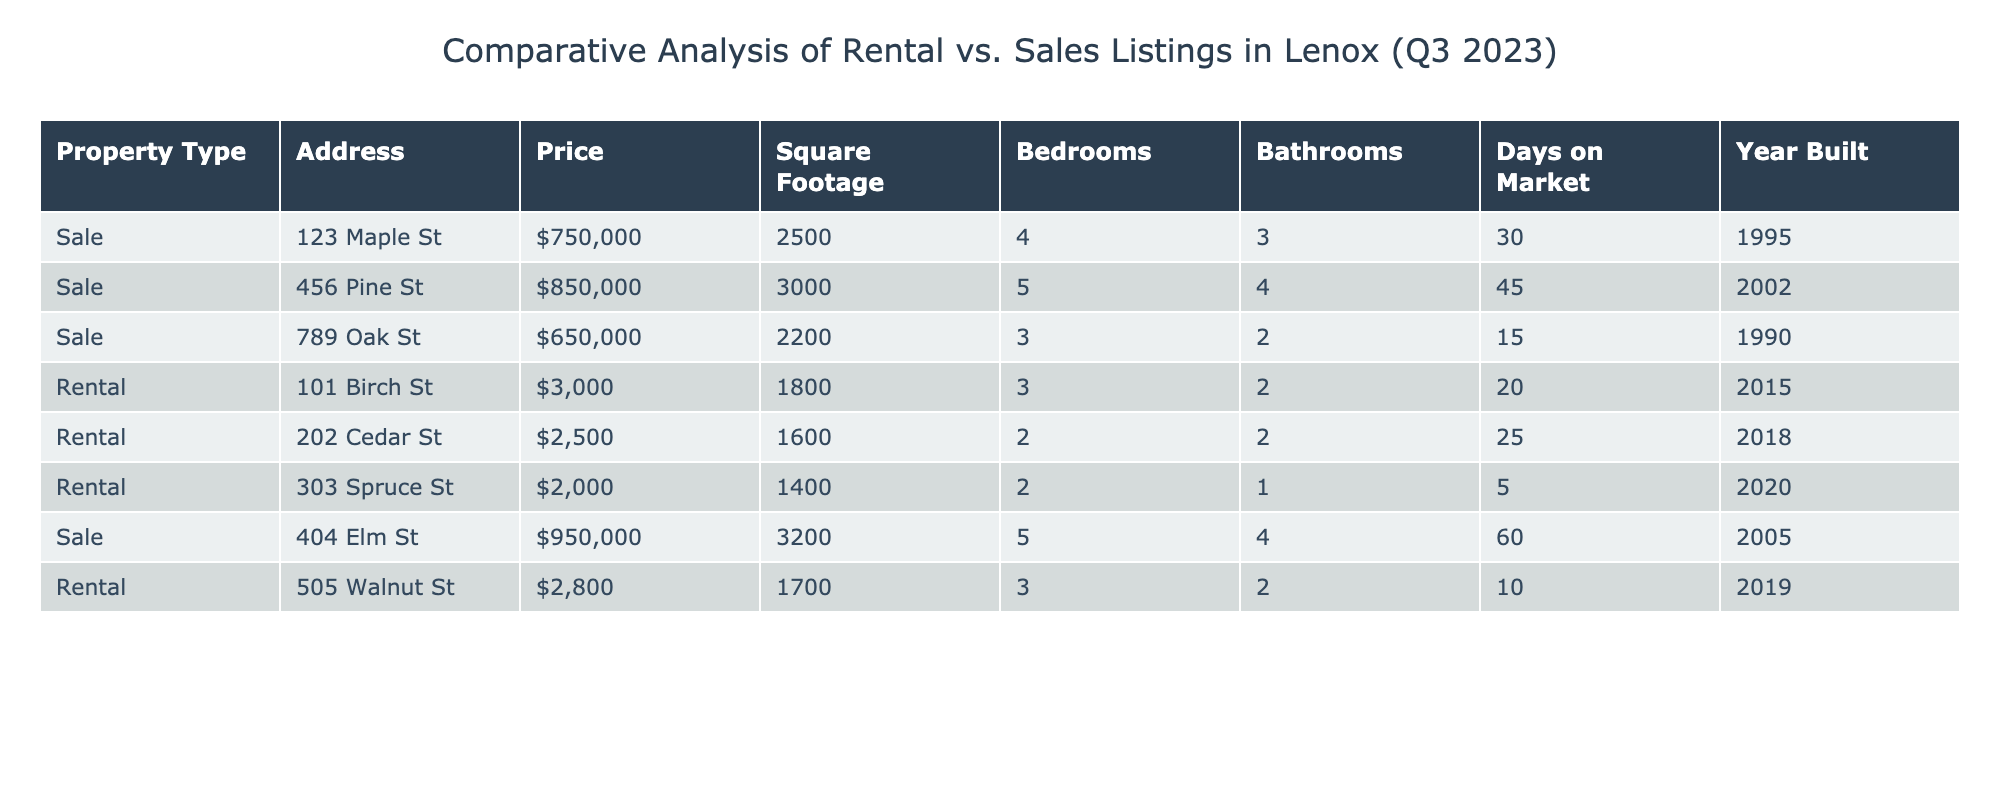What is the highest listing price among the sales properties? The maximum listing price for sales properties can be found from the 'Listing_Price' column for Sale entries. The highest value is 950000 for the property at 404 Elm St.
Answer: 950000 How many rental properties have more than 2 bedrooms? From the table, I will count the rental properties with the 'Bedrooms' column indicating more than 2. There are 2 properties: 101 Birch St (3 bedrooms) and 505 Walnut St (3 bedrooms).
Answer: 2 What is the average square footage of all properties listed for sale? To calculate the average square footage of sale properties: the total square footage for sales is 2500 + 3000 + 2200 + 3200 = 10900. There are 4 sale listings, so the average is 10900 / 4 = 2725.
Answer: 2725 Is there any property built after 2015 that is for sale? Checking the 'Year_Built' column for Sale properties, the years are 1995, 2002, 1990, and 2005. All properties have a year built before 2015.
Answer: No Which rental property has the lowest monthly rent? From the 'Monthly_Rent' column, the rental properties show monthly rents of 3000, 2500, 2000, and 2800. The lowest rent is 2000 for the property at 303 Spruce St.
Answer: 2000 How much more expensive on average are the sales properties compared to the rental properties? First, I sum the sale prices (750000 + 850000 + 650000 + 950000 = 3200000) dividing by the number of sales (4), giving an average sales price of 800000. For rentals, I sum the rents (3000 + 2500 + 2000 + 2800 = 10300) dividing by 4, giving an average rent of 2575. The difference is 800000 - 2575 = 797425.
Answer: 797425 What is the total number of bedrooms in rental properties? Adding the 'Bedrooms' for rental properties gives us 3 + 2 + 2 + 3 = 10.
Answer: 10 Is there a property with 5 bedrooms available for rent? Checking the 'Bedrooms' column for rental properties reveals that the maximum is 3 bedrooms. Thus, there are no properties with 5 bedrooms for rent.
Answer: No 